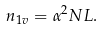Convert formula to latex. <formula><loc_0><loc_0><loc_500><loc_500>n _ { 1 v } = \alpha ^ { 2 } N L .</formula> 